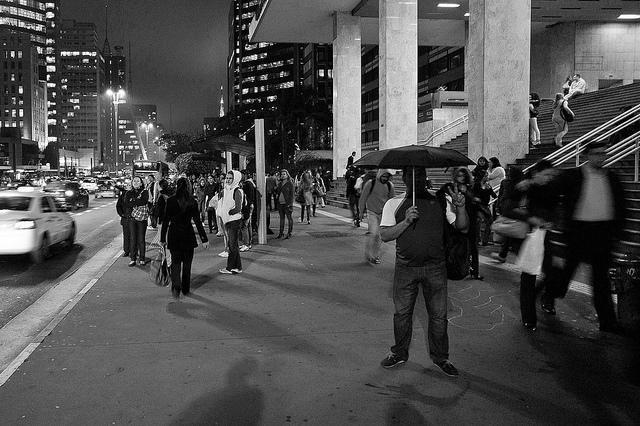How many people are in the photo?
Give a very brief answer. 5. 